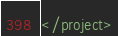Convert code to text. <code><loc_0><loc_0><loc_500><loc_500><_XML_></project></code> 